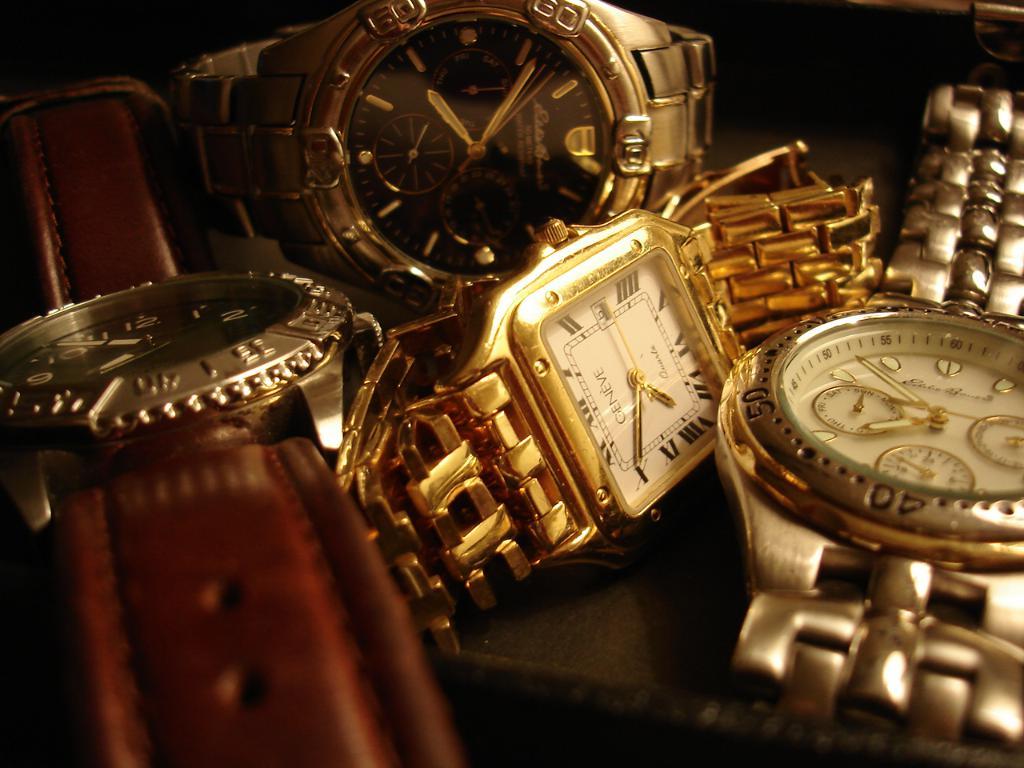What time is on the gold watch?
Offer a very short reply. 7:50. 